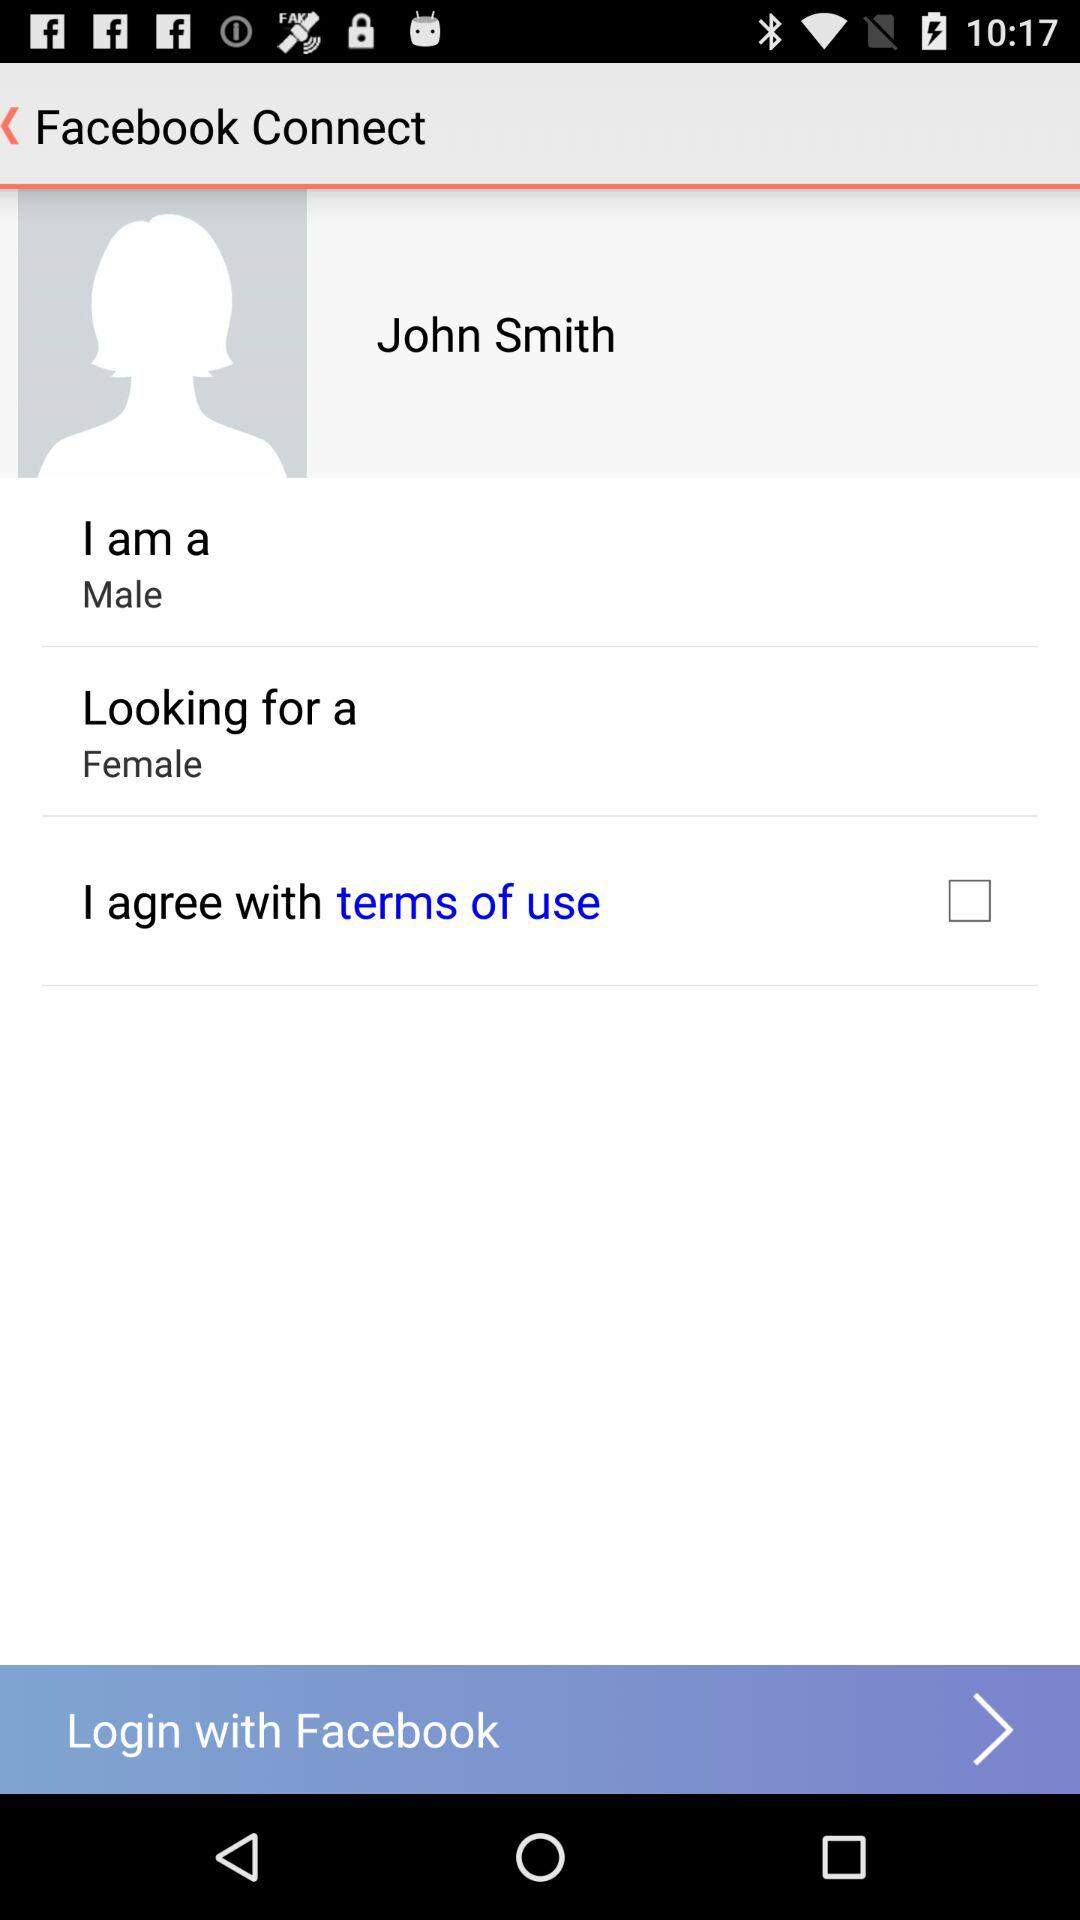Which option is unchecked? The unchecked option is "I agree with terms of use". 